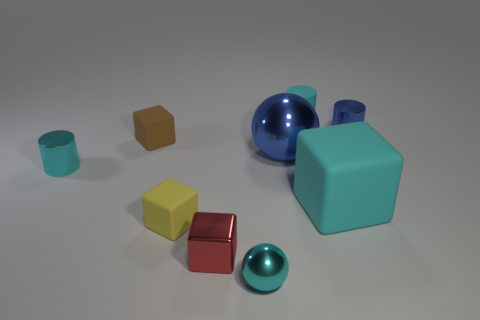How many cyan cylinders must be subtracted to get 1 cyan cylinders? 1 Subtract all small blue cylinders. How many cylinders are left? 2 Add 9 yellow matte blocks. How many yellow matte blocks are left? 10 Add 2 yellow spheres. How many yellow spheres exist? 2 Add 1 big blue things. How many objects exist? 10 Subtract all red blocks. How many blocks are left? 3 Subtract 0 gray cylinders. How many objects are left? 9 Subtract all cubes. How many objects are left? 5 Subtract 2 cylinders. How many cylinders are left? 1 Subtract all brown spheres. Subtract all red cylinders. How many spheres are left? 2 